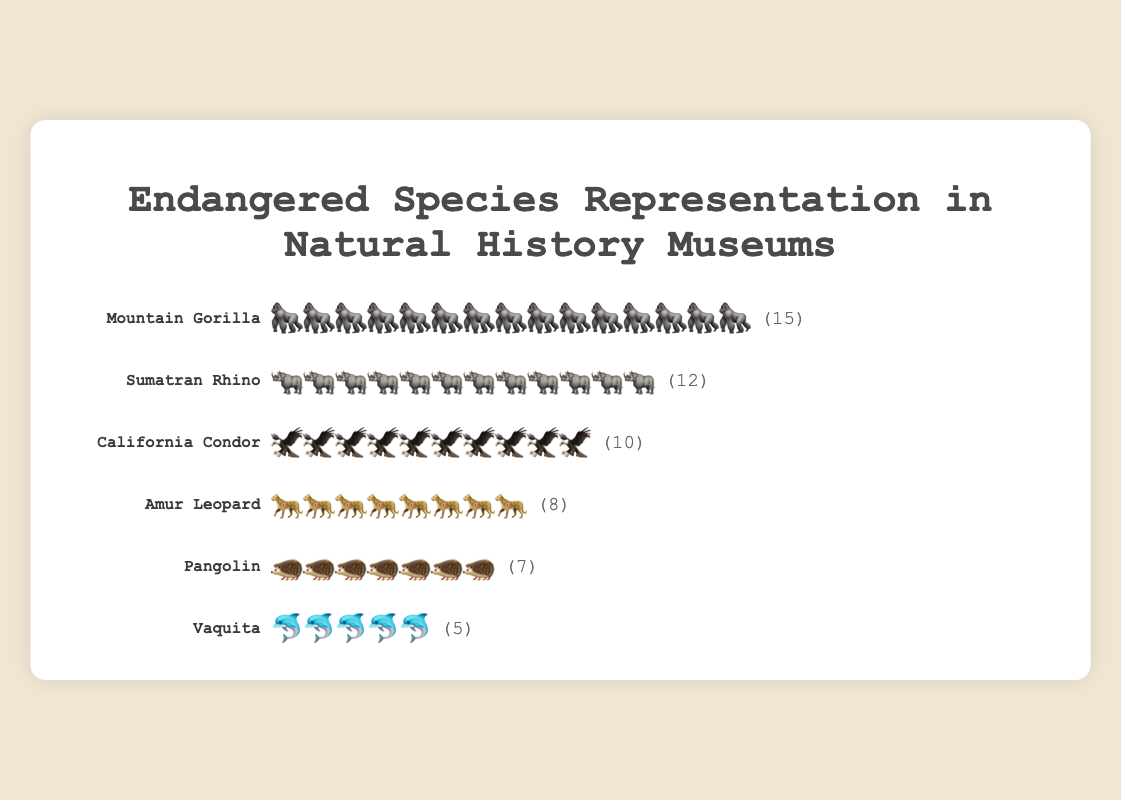Which species is represented by 🦍 icons? The chart shows that the species represented by 🦍 icons is the Mountain Gorilla. It's positioned at the top of the chart and clearly labeled.
Answer: Mountain Gorilla How many museums represent the California Condor? By looking at the chart, we can see that the California Condor is represented by 10 icons, each icon symbolizing one museum. There's also the number 10 in parentheses next to the icons.
Answer: 10 Which species has the fewest museum representations? The species with the fewest icons is the Vaquita, represented by 5 🐬 icons on the chart. This is confirmed by the number 5 in parentheses.
Answer: Vaquita What is the total number of museums that represent either the Sumatran Rhino or the Amur Leopard? The Sumatran Rhino is represented by 12 🦏 icons and the Amur Leopard by 8 🐆 icons. Adding these two numbers provides the total: 12 + 8 = 20.
Answer: 20 How many more museums represent the Mountain Gorilla compared to the Pangolin? The Mountain Gorilla is represented by 15 icons and the Pangolin by 7 icons. The difference in representation is calculated as 15 - 7 = 8.
Answer: 8 Which species are represented by more than 10 museums? By examining the icons, we see that Mountain Gorilla (15) and Sumatran Rhino (12) each have more than 10 museum representations.
Answer: Mountain Gorilla, Sumatran Rhino How many total museums are represented across all the species? Summing the number of museums for each species: 15 (Mountain Gorilla) + 12 (Sumatran Rhino) + 10 (California Condor) + 8 (Amur Leopard) + 7 (Pangolin) + 5 (Vaquita) = 57.
Answer: 57 Which species is represented by a different animal icon than expected? Each species is represented by a suitable animal icon. For example, the Mountain Gorilla by 🦍, the Sumatran Rhino by 🦏, etc. No species seems to be represented by an unexpected icon.
Answer: None Is the California Condor represented in more or fewer museums than the Amur Leopard? Comparing the numbers, California Condor (10) has more museum representations than the Amur Leopard (8).
Answer: More What fraction of the represented museums have exhibits of the Mountain Gorilla? The Mountain Gorilla is represented in 15 museums out of a total of 57 museums. The fraction is 15/57, which simplifies to approximately 0.263.
Answer: 0.263 